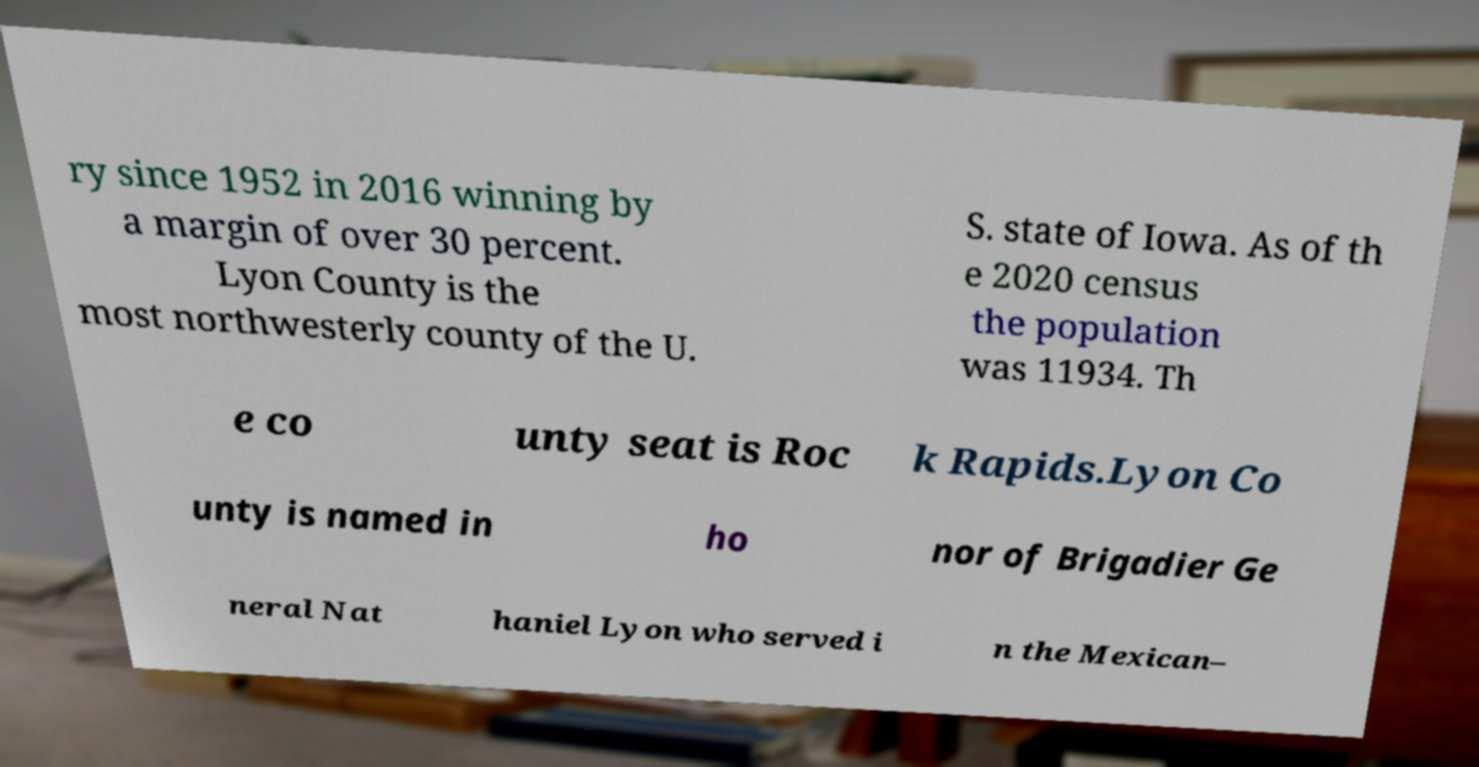Could you extract and type out the text from this image? ry since 1952 in 2016 winning by a margin of over 30 percent. Lyon County is the most northwesterly county of the U. S. state of Iowa. As of th e 2020 census the population was 11934. Th e co unty seat is Roc k Rapids.Lyon Co unty is named in ho nor of Brigadier Ge neral Nat haniel Lyon who served i n the Mexican– 